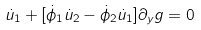<formula> <loc_0><loc_0><loc_500><loc_500>\dot { u } _ { 1 } + [ \dot { \phi } _ { 1 } \dot { u } _ { 2 } - \dot { \phi } _ { 2 } \dot { u } _ { 1 } ] \partial _ { y } g = 0</formula> 